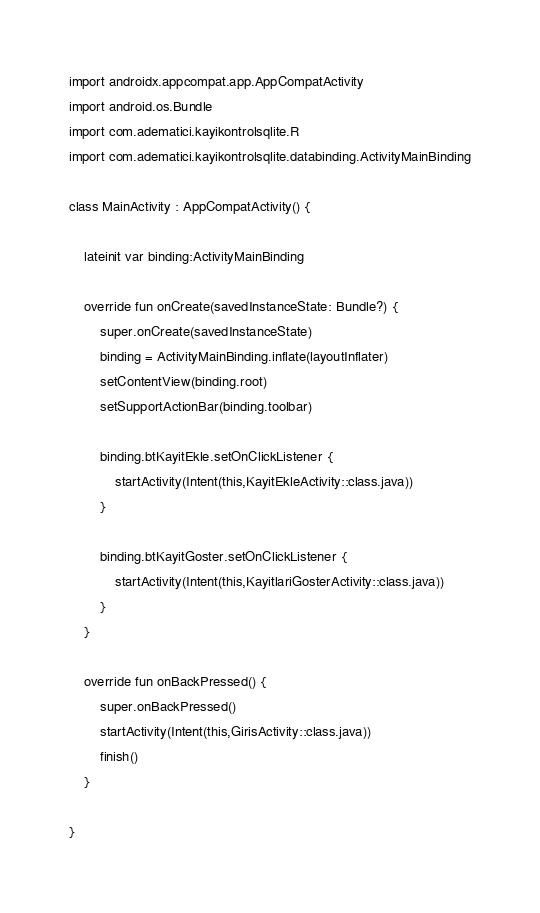Convert code to text. <code><loc_0><loc_0><loc_500><loc_500><_Kotlin_>import androidx.appcompat.app.AppCompatActivity
import android.os.Bundle
import com.adematici.kayikontrolsqlite.R
import com.adematici.kayikontrolsqlite.databinding.ActivityMainBinding

class MainActivity : AppCompatActivity() {

    lateinit var binding:ActivityMainBinding

    override fun onCreate(savedInstanceState: Bundle?) {
        super.onCreate(savedInstanceState)
        binding = ActivityMainBinding.inflate(layoutInflater)
        setContentView(binding.root)
        setSupportActionBar(binding.toolbar)

        binding.btKayitEkle.setOnClickListener {
            startActivity(Intent(this,KayitEkleActivity::class.java))
        }

        binding.btKayitGoster.setOnClickListener {
            startActivity(Intent(this,KayitlariGosterActivity::class.java))
        }
    }

    override fun onBackPressed() {
        super.onBackPressed()
        startActivity(Intent(this,GirisActivity::class.java))
        finish()
    }

}</code> 